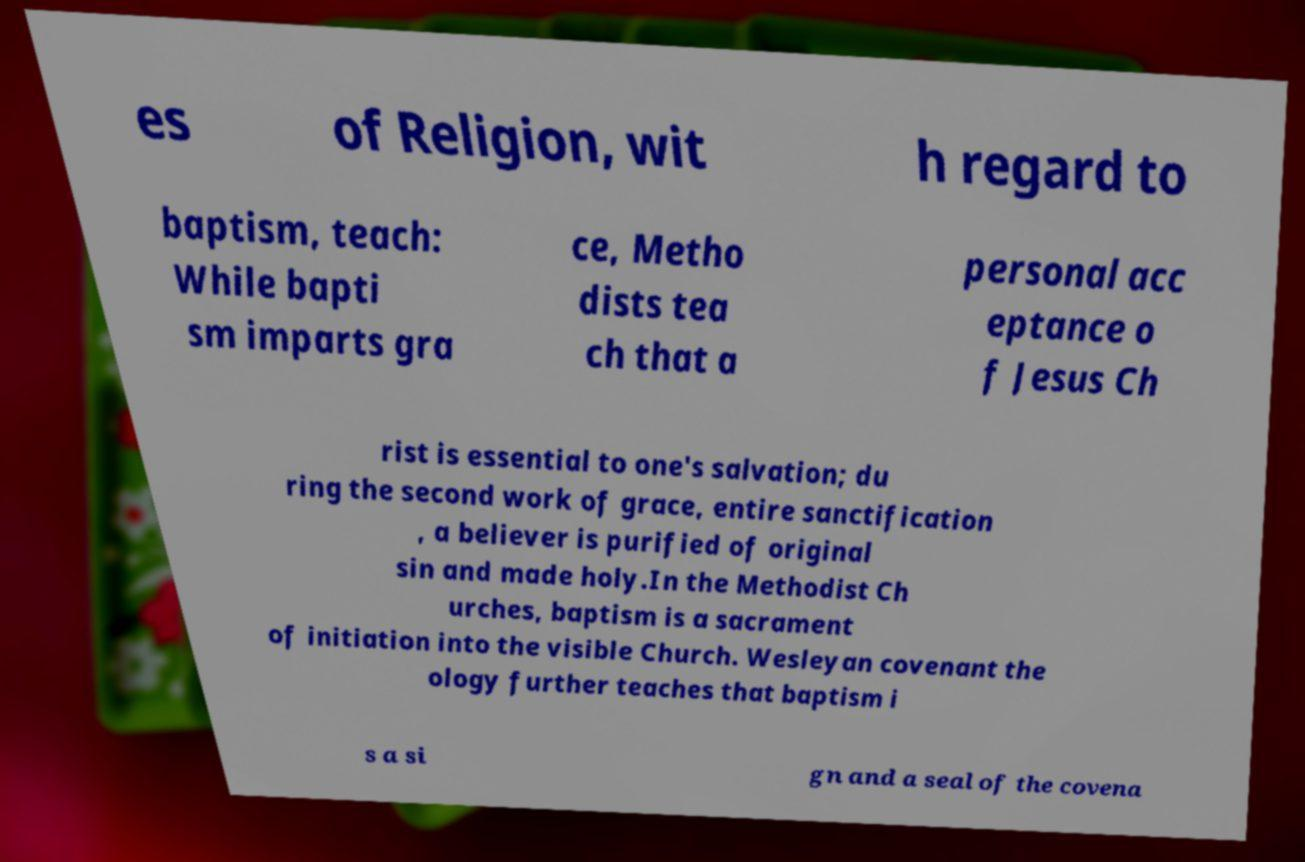I need the written content from this picture converted into text. Can you do that? es of Religion, wit h regard to baptism, teach: While bapti sm imparts gra ce, Metho dists tea ch that a personal acc eptance o f Jesus Ch rist is essential to one's salvation; du ring the second work of grace, entire sanctification , a believer is purified of original sin and made holy.In the Methodist Ch urches, baptism is a sacrament of initiation into the visible Church. Wesleyan covenant the ology further teaches that baptism i s a si gn and a seal of the covena 